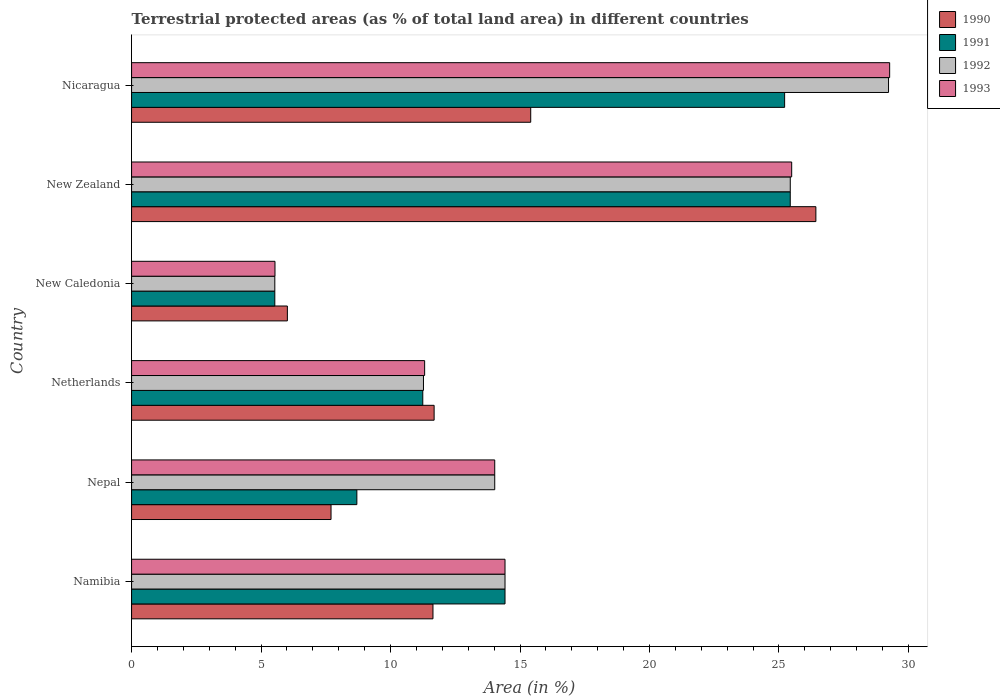How many different coloured bars are there?
Offer a terse response. 4. Are the number of bars per tick equal to the number of legend labels?
Provide a succinct answer. Yes. Are the number of bars on each tick of the Y-axis equal?
Ensure brevity in your answer.  Yes. How many bars are there on the 3rd tick from the top?
Your answer should be compact. 4. What is the label of the 2nd group of bars from the top?
Offer a very short reply. New Zealand. In how many cases, is the number of bars for a given country not equal to the number of legend labels?
Provide a short and direct response. 0. What is the percentage of terrestrial protected land in 1992 in New Zealand?
Provide a short and direct response. 25.44. Across all countries, what is the maximum percentage of terrestrial protected land in 1993?
Offer a terse response. 29.27. Across all countries, what is the minimum percentage of terrestrial protected land in 1993?
Your response must be concise. 5.54. In which country was the percentage of terrestrial protected land in 1991 maximum?
Ensure brevity in your answer.  New Zealand. In which country was the percentage of terrestrial protected land in 1992 minimum?
Provide a succinct answer. New Caledonia. What is the total percentage of terrestrial protected land in 1990 in the graph?
Provide a succinct answer. 78.88. What is the difference between the percentage of terrestrial protected land in 1991 in Netherlands and that in New Caledonia?
Make the answer very short. 5.71. What is the difference between the percentage of terrestrial protected land in 1993 in Nepal and the percentage of terrestrial protected land in 1990 in New Zealand?
Offer a very short reply. -12.4. What is the average percentage of terrestrial protected land in 1993 per country?
Make the answer very short. 16.68. What is the difference between the percentage of terrestrial protected land in 1991 and percentage of terrestrial protected land in 1992 in Netherlands?
Keep it short and to the point. -0.03. In how many countries, is the percentage of terrestrial protected land in 1993 greater than 12 %?
Offer a terse response. 4. What is the ratio of the percentage of terrestrial protected land in 1990 in Namibia to that in New Zealand?
Your answer should be compact. 0.44. Is the percentage of terrestrial protected land in 1990 in Namibia less than that in Nepal?
Your answer should be compact. No. Is the difference between the percentage of terrestrial protected land in 1991 in Nepal and Nicaragua greater than the difference between the percentage of terrestrial protected land in 1992 in Nepal and Nicaragua?
Provide a short and direct response. No. What is the difference between the highest and the second highest percentage of terrestrial protected land in 1990?
Provide a succinct answer. 11.01. What is the difference between the highest and the lowest percentage of terrestrial protected land in 1990?
Keep it short and to the point. 20.41. In how many countries, is the percentage of terrestrial protected land in 1991 greater than the average percentage of terrestrial protected land in 1991 taken over all countries?
Your response must be concise. 2. What does the 3rd bar from the top in New Caledonia represents?
Make the answer very short. 1991. How many bars are there?
Your answer should be compact. 24. Are the values on the major ticks of X-axis written in scientific E-notation?
Give a very brief answer. No. Where does the legend appear in the graph?
Ensure brevity in your answer.  Top right. How many legend labels are there?
Provide a succinct answer. 4. How are the legend labels stacked?
Your response must be concise. Vertical. What is the title of the graph?
Provide a short and direct response. Terrestrial protected areas (as % of total land area) in different countries. What is the label or title of the X-axis?
Your answer should be very brief. Area (in %). What is the label or title of the Y-axis?
Make the answer very short. Country. What is the Area (in %) in 1990 in Namibia?
Provide a succinct answer. 11.64. What is the Area (in %) in 1991 in Namibia?
Provide a short and direct response. 14.42. What is the Area (in %) in 1992 in Namibia?
Keep it short and to the point. 14.42. What is the Area (in %) in 1993 in Namibia?
Provide a short and direct response. 14.42. What is the Area (in %) in 1990 in Nepal?
Keep it short and to the point. 7.7. What is the Area (in %) in 1991 in Nepal?
Offer a very short reply. 8.7. What is the Area (in %) of 1992 in Nepal?
Provide a short and direct response. 14.02. What is the Area (in %) of 1993 in Nepal?
Keep it short and to the point. 14.02. What is the Area (in %) of 1990 in Netherlands?
Give a very brief answer. 11.68. What is the Area (in %) of 1991 in Netherlands?
Provide a succinct answer. 11.25. What is the Area (in %) in 1992 in Netherlands?
Give a very brief answer. 11.27. What is the Area (in %) in 1993 in Netherlands?
Offer a terse response. 11.32. What is the Area (in %) in 1990 in New Caledonia?
Keep it short and to the point. 6.02. What is the Area (in %) in 1991 in New Caledonia?
Your answer should be compact. 5.53. What is the Area (in %) in 1992 in New Caledonia?
Make the answer very short. 5.53. What is the Area (in %) in 1993 in New Caledonia?
Offer a terse response. 5.54. What is the Area (in %) in 1990 in New Zealand?
Your answer should be very brief. 26.42. What is the Area (in %) of 1991 in New Zealand?
Offer a terse response. 25.44. What is the Area (in %) in 1992 in New Zealand?
Keep it short and to the point. 25.44. What is the Area (in %) of 1993 in New Zealand?
Make the answer very short. 25.49. What is the Area (in %) of 1990 in Nicaragua?
Keep it short and to the point. 15.41. What is the Area (in %) in 1991 in Nicaragua?
Your answer should be very brief. 25.22. What is the Area (in %) of 1992 in Nicaragua?
Give a very brief answer. 29.23. What is the Area (in %) of 1993 in Nicaragua?
Ensure brevity in your answer.  29.27. Across all countries, what is the maximum Area (in %) of 1990?
Make the answer very short. 26.42. Across all countries, what is the maximum Area (in %) in 1991?
Provide a short and direct response. 25.44. Across all countries, what is the maximum Area (in %) of 1992?
Offer a very short reply. 29.23. Across all countries, what is the maximum Area (in %) of 1993?
Ensure brevity in your answer.  29.27. Across all countries, what is the minimum Area (in %) of 1990?
Provide a short and direct response. 6.02. Across all countries, what is the minimum Area (in %) of 1991?
Your answer should be compact. 5.53. Across all countries, what is the minimum Area (in %) in 1992?
Your answer should be very brief. 5.53. Across all countries, what is the minimum Area (in %) in 1993?
Your answer should be very brief. 5.54. What is the total Area (in %) of 1990 in the graph?
Your answer should be compact. 78.88. What is the total Area (in %) in 1991 in the graph?
Ensure brevity in your answer.  90.55. What is the total Area (in %) of 1992 in the graph?
Ensure brevity in your answer.  99.91. What is the total Area (in %) of 1993 in the graph?
Keep it short and to the point. 100.06. What is the difference between the Area (in %) in 1990 in Namibia and that in Nepal?
Make the answer very short. 3.94. What is the difference between the Area (in %) in 1991 in Namibia and that in Nepal?
Make the answer very short. 5.72. What is the difference between the Area (in %) of 1992 in Namibia and that in Nepal?
Your answer should be very brief. 0.4. What is the difference between the Area (in %) in 1993 in Namibia and that in Nepal?
Ensure brevity in your answer.  0.4. What is the difference between the Area (in %) of 1990 in Namibia and that in Netherlands?
Your answer should be very brief. -0.04. What is the difference between the Area (in %) of 1991 in Namibia and that in Netherlands?
Provide a succinct answer. 3.18. What is the difference between the Area (in %) in 1992 in Namibia and that in Netherlands?
Provide a succinct answer. 3.15. What is the difference between the Area (in %) of 1993 in Namibia and that in Netherlands?
Offer a very short reply. 3.1. What is the difference between the Area (in %) of 1990 in Namibia and that in New Caledonia?
Your response must be concise. 5.62. What is the difference between the Area (in %) in 1991 in Namibia and that in New Caledonia?
Your answer should be very brief. 8.89. What is the difference between the Area (in %) of 1992 in Namibia and that in New Caledonia?
Your response must be concise. 8.89. What is the difference between the Area (in %) of 1993 in Namibia and that in New Caledonia?
Ensure brevity in your answer.  8.88. What is the difference between the Area (in %) of 1990 in Namibia and that in New Zealand?
Your response must be concise. -14.79. What is the difference between the Area (in %) in 1991 in Namibia and that in New Zealand?
Your answer should be very brief. -11.01. What is the difference between the Area (in %) in 1992 in Namibia and that in New Zealand?
Provide a succinct answer. -11.02. What is the difference between the Area (in %) in 1993 in Namibia and that in New Zealand?
Offer a terse response. -11.07. What is the difference between the Area (in %) in 1990 in Namibia and that in Nicaragua?
Make the answer very short. -3.77. What is the difference between the Area (in %) of 1991 in Namibia and that in Nicaragua?
Provide a succinct answer. -10.8. What is the difference between the Area (in %) of 1992 in Namibia and that in Nicaragua?
Make the answer very short. -14.81. What is the difference between the Area (in %) of 1993 in Namibia and that in Nicaragua?
Keep it short and to the point. -14.85. What is the difference between the Area (in %) of 1990 in Nepal and that in Netherlands?
Your answer should be very brief. -3.98. What is the difference between the Area (in %) in 1991 in Nepal and that in Netherlands?
Your answer should be very brief. -2.55. What is the difference between the Area (in %) in 1992 in Nepal and that in Netherlands?
Your answer should be compact. 2.75. What is the difference between the Area (in %) of 1993 in Nepal and that in Netherlands?
Your answer should be compact. 2.71. What is the difference between the Area (in %) in 1990 in Nepal and that in New Caledonia?
Your answer should be very brief. 1.69. What is the difference between the Area (in %) in 1991 in Nepal and that in New Caledonia?
Your answer should be very brief. 3.17. What is the difference between the Area (in %) of 1992 in Nepal and that in New Caledonia?
Your answer should be very brief. 8.49. What is the difference between the Area (in %) of 1993 in Nepal and that in New Caledonia?
Make the answer very short. 8.49. What is the difference between the Area (in %) in 1990 in Nepal and that in New Zealand?
Make the answer very short. -18.72. What is the difference between the Area (in %) of 1991 in Nepal and that in New Zealand?
Your response must be concise. -16.74. What is the difference between the Area (in %) of 1992 in Nepal and that in New Zealand?
Your answer should be very brief. -11.41. What is the difference between the Area (in %) in 1993 in Nepal and that in New Zealand?
Give a very brief answer. -11.47. What is the difference between the Area (in %) of 1990 in Nepal and that in Nicaragua?
Your response must be concise. -7.71. What is the difference between the Area (in %) of 1991 in Nepal and that in Nicaragua?
Keep it short and to the point. -16.52. What is the difference between the Area (in %) of 1992 in Nepal and that in Nicaragua?
Your response must be concise. -15.21. What is the difference between the Area (in %) in 1993 in Nepal and that in Nicaragua?
Offer a very short reply. -15.25. What is the difference between the Area (in %) of 1990 in Netherlands and that in New Caledonia?
Keep it short and to the point. 5.67. What is the difference between the Area (in %) of 1991 in Netherlands and that in New Caledonia?
Make the answer very short. 5.71. What is the difference between the Area (in %) of 1992 in Netherlands and that in New Caledonia?
Give a very brief answer. 5.74. What is the difference between the Area (in %) of 1993 in Netherlands and that in New Caledonia?
Offer a very short reply. 5.78. What is the difference between the Area (in %) in 1990 in Netherlands and that in New Zealand?
Provide a succinct answer. -14.74. What is the difference between the Area (in %) of 1991 in Netherlands and that in New Zealand?
Your answer should be very brief. -14.19. What is the difference between the Area (in %) in 1992 in Netherlands and that in New Zealand?
Make the answer very short. -14.16. What is the difference between the Area (in %) of 1993 in Netherlands and that in New Zealand?
Your answer should be very brief. -14.17. What is the difference between the Area (in %) of 1990 in Netherlands and that in Nicaragua?
Give a very brief answer. -3.73. What is the difference between the Area (in %) of 1991 in Netherlands and that in Nicaragua?
Provide a succinct answer. -13.97. What is the difference between the Area (in %) in 1992 in Netherlands and that in Nicaragua?
Make the answer very short. -17.96. What is the difference between the Area (in %) of 1993 in Netherlands and that in Nicaragua?
Your answer should be very brief. -17.96. What is the difference between the Area (in %) in 1990 in New Caledonia and that in New Zealand?
Your answer should be very brief. -20.41. What is the difference between the Area (in %) in 1991 in New Caledonia and that in New Zealand?
Ensure brevity in your answer.  -19.9. What is the difference between the Area (in %) of 1992 in New Caledonia and that in New Zealand?
Keep it short and to the point. -19.9. What is the difference between the Area (in %) in 1993 in New Caledonia and that in New Zealand?
Your response must be concise. -19.95. What is the difference between the Area (in %) of 1990 in New Caledonia and that in Nicaragua?
Provide a short and direct response. -9.4. What is the difference between the Area (in %) in 1991 in New Caledonia and that in Nicaragua?
Keep it short and to the point. -19.69. What is the difference between the Area (in %) of 1992 in New Caledonia and that in Nicaragua?
Offer a very short reply. -23.7. What is the difference between the Area (in %) of 1993 in New Caledonia and that in Nicaragua?
Keep it short and to the point. -23.74. What is the difference between the Area (in %) in 1990 in New Zealand and that in Nicaragua?
Your response must be concise. 11.01. What is the difference between the Area (in %) in 1991 in New Zealand and that in Nicaragua?
Provide a succinct answer. 0.22. What is the difference between the Area (in %) in 1992 in New Zealand and that in Nicaragua?
Your answer should be very brief. -3.79. What is the difference between the Area (in %) of 1993 in New Zealand and that in Nicaragua?
Your answer should be very brief. -3.78. What is the difference between the Area (in %) of 1990 in Namibia and the Area (in %) of 1991 in Nepal?
Provide a succinct answer. 2.94. What is the difference between the Area (in %) of 1990 in Namibia and the Area (in %) of 1992 in Nepal?
Offer a very short reply. -2.39. What is the difference between the Area (in %) in 1990 in Namibia and the Area (in %) in 1993 in Nepal?
Provide a succinct answer. -2.39. What is the difference between the Area (in %) in 1991 in Namibia and the Area (in %) in 1992 in Nepal?
Provide a short and direct response. 0.4. What is the difference between the Area (in %) of 1991 in Namibia and the Area (in %) of 1993 in Nepal?
Make the answer very short. 0.4. What is the difference between the Area (in %) in 1992 in Namibia and the Area (in %) in 1993 in Nepal?
Ensure brevity in your answer.  0.4. What is the difference between the Area (in %) in 1990 in Namibia and the Area (in %) in 1991 in Netherlands?
Offer a terse response. 0.39. What is the difference between the Area (in %) of 1990 in Namibia and the Area (in %) of 1992 in Netherlands?
Offer a very short reply. 0.37. What is the difference between the Area (in %) of 1990 in Namibia and the Area (in %) of 1993 in Netherlands?
Ensure brevity in your answer.  0.32. What is the difference between the Area (in %) in 1991 in Namibia and the Area (in %) in 1992 in Netherlands?
Give a very brief answer. 3.15. What is the difference between the Area (in %) in 1991 in Namibia and the Area (in %) in 1993 in Netherlands?
Make the answer very short. 3.1. What is the difference between the Area (in %) of 1992 in Namibia and the Area (in %) of 1993 in Netherlands?
Offer a terse response. 3.1. What is the difference between the Area (in %) of 1990 in Namibia and the Area (in %) of 1991 in New Caledonia?
Offer a very short reply. 6.11. What is the difference between the Area (in %) of 1990 in Namibia and the Area (in %) of 1992 in New Caledonia?
Give a very brief answer. 6.11. What is the difference between the Area (in %) of 1990 in Namibia and the Area (in %) of 1993 in New Caledonia?
Offer a terse response. 6.1. What is the difference between the Area (in %) in 1991 in Namibia and the Area (in %) in 1992 in New Caledonia?
Provide a short and direct response. 8.89. What is the difference between the Area (in %) in 1991 in Namibia and the Area (in %) in 1993 in New Caledonia?
Keep it short and to the point. 8.88. What is the difference between the Area (in %) in 1992 in Namibia and the Area (in %) in 1993 in New Caledonia?
Give a very brief answer. 8.88. What is the difference between the Area (in %) in 1990 in Namibia and the Area (in %) in 1991 in New Zealand?
Ensure brevity in your answer.  -13.8. What is the difference between the Area (in %) of 1990 in Namibia and the Area (in %) of 1992 in New Zealand?
Provide a succinct answer. -13.8. What is the difference between the Area (in %) in 1990 in Namibia and the Area (in %) in 1993 in New Zealand?
Provide a succinct answer. -13.85. What is the difference between the Area (in %) of 1991 in Namibia and the Area (in %) of 1992 in New Zealand?
Ensure brevity in your answer.  -11.02. What is the difference between the Area (in %) in 1991 in Namibia and the Area (in %) in 1993 in New Zealand?
Provide a succinct answer. -11.07. What is the difference between the Area (in %) of 1992 in Namibia and the Area (in %) of 1993 in New Zealand?
Your answer should be very brief. -11.07. What is the difference between the Area (in %) of 1990 in Namibia and the Area (in %) of 1991 in Nicaragua?
Offer a very short reply. -13.58. What is the difference between the Area (in %) in 1990 in Namibia and the Area (in %) in 1992 in Nicaragua?
Your response must be concise. -17.59. What is the difference between the Area (in %) of 1990 in Namibia and the Area (in %) of 1993 in Nicaragua?
Ensure brevity in your answer.  -17.64. What is the difference between the Area (in %) in 1991 in Namibia and the Area (in %) in 1992 in Nicaragua?
Provide a succinct answer. -14.81. What is the difference between the Area (in %) of 1991 in Namibia and the Area (in %) of 1993 in Nicaragua?
Offer a very short reply. -14.85. What is the difference between the Area (in %) of 1992 in Namibia and the Area (in %) of 1993 in Nicaragua?
Make the answer very short. -14.85. What is the difference between the Area (in %) of 1990 in Nepal and the Area (in %) of 1991 in Netherlands?
Your answer should be compact. -3.54. What is the difference between the Area (in %) in 1990 in Nepal and the Area (in %) in 1992 in Netherlands?
Give a very brief answer. -3.57. What is the difference between the Area (in %) of 1990 in Nepal and the Area (in %) of 1993 in Netherlands?
Your answer should be compact. -3.61. What is the difference between the Area (in %) in 1991 in Nepal and the Area (in %) in 1992 in Netherlands?
Your answer should be compact. -2.57. What is the difference between the Area (in %) of 1991 in Nepal and the Area (in %) of 1993 in Netherlands?
Offer a terse response. -2.62. What is the difference between the Area (in %) in 1992 in Nepal and the Area (in %) in 1993 in Netherlands?
Your response must be concise. 2.71. What is the difference between the Area (in %) in 1990 in Nepal and the Area (in %) in 1991 in New Caledonia?
Provide a succinct answer. 2.17. What is the difference between the Area (in %) of 1990 in Nepal and the Area (in %) of 1992 in New Caledonia?
Provide a succinct answer. 2.17. What is the difference between the Area (in %) in 1990 in Nepal and the Area (in %) in 1993 in New Caledonia?
Your answer should be compact. 2.16. What is the difference between the Area (in %) in 1991 in Nepal and the Area (in %) in 1992 in New Caledonia?
Provide a succinct answer. 3.17. What is the difference between the Area (in %) of 1991 in Nepal and the Area (in %) of 1993 in New Caledonia?
Offer a very short reply. 3.16. What is the difference between the Area (in %) in 1992 in Nepal and the Area (in %) in 1993 in New Caledonia?
Give a very brief answer. 8.49. What is the difference between the Area (in %) of 1990 in Nepal and the Area (in %) of 1991 in New Zealand?
Your response must be concise. -17.73. What is the difference between the Area (in %) in 1990 in Nepal and the Area (in %) in 1992 in New Zealand?
Make the answer very short. -17.73. What is the difference between the Area (in %) in 1990 in Nepal and the Area (in %) in 1993 in New Zealand?
Your answer should be compact. -17.79. What is the difference between the Area (in %) of 1991 in Nepal and the Area (in %) of 1992 in New Zealand?
Your response must be concise. -16.74. What is the difference between the Area (in %) in 1991 in Nepal and the Area (in %) in 1993 in New Zealand?
Keep it short and to the point. -16.79. What is the difference between the Area (in %) in 1992 in Nepal and the Area (in %) in 1993 in New Zealand?
Provide a short and direct response. -11.47. What is the difference between the Area (in %) in 1990 in Nepal and the Area (in %) in 1991 in Nicaragua?
Your answer should be compact. -17.52. What is the difference between the Area (in %) of 1990 in Nepal and the Area (in %) of 1992 in Nicaragua?
Make the answer very short. -21.53. What is the difference between the Area (in %) of 1990 in Nepal and the Area (in %) of 1993 in Nicaragua?
Keep it short and to the point. -21.57. What is the difference between the Area (in %) of 1991 in Nepal and the Area (in %) of 1992 in Nicaragua?
Ensure brevity in your answer.  -20.53. What is the difference between the Area (in %) in 1991 in Nepal and the Area (in %) in 1993 in Nicaragua?
Give a very brief answer. -20.57. What is the difference between the Area (in %) in 1992 in Nepal and the Area (in %) in 1993 in Nicaragua?
Your answer should be very brief. -15.25. What is the difference between the Area (in %) of 1990 in Netherlands and the Area (in %) of 1991 in New Caledonia?
Your response must be concise. 6.15. What is the difference between the Area (in %) of 1990 in Netherlands and the Area (in %) of 1992 in New Caledonia?
Offer a terse response. 6.15. What is the difference between the Area (in %) in 1990 in Netherlands and the Area (in %) in 1993 in New Caledonia?
Provide a short and direct response. 6.15. What is the difference between the Area (in %) in 1991 in Netherlands and the Area (in %) in 1992 in New Caledonia?
Ensure brevity in your answer.  5.71. What is the difference between the Area (in %) of 1991 in Netherlands and the Area (in %) of 1993 in New Caledonia?
Offer a terse response. 5.71. What is the difference between the Area (in %) in 1992 in Netherlands and the Area (in %) in 1993 in New Caledonia?
Make the answer very short. 5.73. What is the difference between the Area (in %) in 1990 in Netherlands and the Area (in %) in 1991 in New Zealand?
Your response must be concise. -13.75. What is the difference between the Area (in %) in 1990 in Netherlands and the Area (in %) in 1992 in New Zealand?
Your answer should be compact. -13.75. What is the difference between the Area (in %) in 1990 in Netherlands and the Area (in %) in 1993 in New Zealand?
Offer a very short reply. -13.81. What is the difference between the Area (in %) of 1991 in Netherlands and the Area (in %) of 1992 in New Zealand?
Give a very brief answer. -14.19. What is the difference between the Area (in %) of 1991 in Netherlands and the Area (in %) of 1993 in New Zealand?
Make the answer very short. -14.25. What is the difference between the Area (in %) in 1992 in Netherlands and the Area (in %) in 1993 in New Zealand?
Your answer should be very brief. -14.22. What is the difference between the Area (in %) in 1990 in Netherlands and the Area (in %) in 1991 in Nicaragua?
Offer a terse response. -13.54. What is the difference between the Area (in %) of 1990 in Netherlands and the Area (in %) of 1992 in Nicaragua?
Provide a short and direct response. -17.55. What is the difference between the Area (in %) of 1990 in Netherlands and the Area (in %) of 1993 in Nicaragua?
Your answer should be very brief. -17.59. What is the difference between the Area (in %) of 1991 in Netherlands and the Area (in %) of 1992 in Nicaragua?
Your answer should be very brief. -17.98. What is the difference between the Area (in %) of 1991 in Netherlands and the Area (in %) of 1993 in Nicaragua?
Offer a very short reply. -18.03. What is the difference between the Area (in %) of 1992 in Netherlands and the Area (in %) of 1993 in Nicaragua?
Make the answer very short. -18. What is the difference between the Area (in %) of 1990 in New Caledonia and the Area (in %) of 1991 in New Zealand?
Offer a very short reply. -19.42. What is the difference between the Area (in %) of 1990 in New Caledonia and the Area (in %) of 1992 in New Zealand?
Offer a very short reply. -19.42. What is the difference between the Area (in %) of 1990 in New Caledonia and the Area (in %) of 1993 in New Zealand?
Give a very brief answer. -19.47. What is the difference between the Area (in %) in 1991 in New Caledonia and the Area (in %) in 1992 in New Zealand?
Offer a terse response. -19.9. What is the difference between the Area (in %) of 1991 in New Caledonia and the Area (in %) of 1993 in New Zealand?
Your response must be concise. -19.96. What is the difference between the Area (in %) in 1992 in New Caledonia and the Area (in %) in 1993 in New Zealand?
Make the answer very short. -19.96. What is the difference between the Area (in %) in 1990 in New Caledonia and the Area (in %) in 1991 in Nicaragua?
Your answer should be compact. -19.2. What is the difference between the Area (in %) in 1990 in New Caledonia and the Area (in %) in 1992 in Nicaragua?
Your response must be concise. -23.21. What is the difference between the Area (in %) in 1990 in New Caledonia and the Area (in %) in 1993 in Nicaragua?
Your answer should be very brief. -23.26. What is the difference between the Area (in %) of 1991 in New Caledonia and the Area (in %) of 1992 in Nicaragua?
Keep it short and to the point. -23.7. What is the difference between the Area (in %) in 1991 in New Caledonia and the Area (in %) in 1993 in Nicaragua?
Your response must be concise. -23.74. What is the difference between the Area (in %) in 1992 in New Caledonia and the Area (in %) in 1993 in Nicaragua?
Provide a short and direct response. -23.74. What is the difference between the Area (in %) in 1990 in New Zealand and the Area (in %) in 1991 in Nicaragua?
Provide a succinct answer. 1.21. What is the difference between the Area (in %) in 1990 in New Zealand and the Area (in %) in 1992 in Nicaragua?
Provide a short and direct response. -2.81. What is the difference between the Area (in %) in 1990 in New Zealand and the Area (in %) in 1993 in Nicaragua?
Offer a terse response. -2.85. What is the difference between the Area (in %) of 1991 in New Zealand and the Area (in %) of 1992 in Nicaragua?
Offer a very short reply. -3.79. What is the difference between the Area (in %) in 1991 in New Zealand and the Area (in %) in 1993 in Nicaragua?
Your response must be concise. -3.84. What is the difference between the Area (in %) of 1992 in New Zealand and the Area (in %) of 1993 in Nicaragua?
Provide a succinct answer. -3.84. What is the average Area (in %) in 1990 per country?
Ensure brevity in your answer.  13.15. What is the average Area (in %) of 1991 per country?
Ensure brevity in your answer.  15.09. What is the average Area (in %) of 1992 per country?
Your answer should be compact. 16.65. What is the average Area (in %) of 1993 per country?
Offer a terse response. 16.68. What is the difference between the Area (in %) in 1990 and Area (in %) in 1991 in Namibia?
Make the answer very short. -2.78. What is the difference between the Area (in %) of 1990 and Area (in %) of 1992 in Namibia?
Make the answer very short. -2.78. What is the difference between the Area (in %) of 1990 and Area (in %) of 1993 in Namibia?
Ensure brevity in your answer.  -2.78. What is the difference between the Area (in %) of 1991 and Area (in %) of 1992 in Namibia?
Offer a very short reply. 0. What is the difference between the Area (in %) in 1992 and Area (in %) in 1993 in Namibia?
Offer a terse response. 0. What is the difference between the Area (in %) of 1990 and Area (in %) of 1991 in Nepal?
Give a very brief answer. -1. What is the difference between the Area (in %) in 1990 and Area (in %) in 1992 in Nepal?
Your response must be concise. -6.32. What is the difference between the Area (in %) in 1990 and Area (in %) in 1993 in Nepal?
Provide a succinct answer. -6.32. What is the difference between the Area (in %) of 1991 and Area (in %) of 1992 in Nepal?
Offer a terse response. -5.32. What is the difference between the Area (in %) of 1991 and Area (in %) of 1993 in Nepal?
Your answer should be very brief. -5.32. What is the difference between the Area (in %) of 1992 and Area (in %) of 1993 in Nepal?
Keep it short and to the point. 0. What is the difference between the Area (in %) of 1990 and Area (in %) of 1991 in Netherlands?
Offer a terse response. 0.44. What is the difference between the Area (in %) of 1990 and Area (in %) of 1992 in Netherlands?
Ensure brevity in your answer.  0.41. What is the difference between the Area (in %) of 1990 and Area (in %) of 1993 in Netherlands?
Offer a very short reply. 0.37. What is the difference between the Area (in %) in 1991 and Area (in %) in 1992 in Netherlands?
Offer a very short reply. -0.03. What is the difference between the Area (in %) in 1991 and Area (in %) in 1993 in Netherlands?
Your answer should be compact. -0.07. What is the difference between the Area (in %) of 1992 and Area (in %) of 1993 in Netherlands?
Offer a very short reply. -0.05. What is the difference between the Area (in %) of 1990 and Area (in %) of 1991 in New Caledonia?
Ensure brevity in your answer.  0.48. What is the difference between the Area (in %) in 1990 and Area (in %) in 1992 in New Caledonia?
Give a very brief answer. 0.48. What is the difference between the Area (in %) in 1990 and Area (in %) in 1993 in New Caledonia?
Offer a very short reply. 0.48. What is the difference between the Area (in %) in 1991 and Area (in %) in 1993 in New Caledonia?
Your answer should be very brief. -0.01. What is the difference between the Area (in %) of 1992 and Area (in %) of 1993 in New Caledonia?
Make the answer very short. -0.01. What is the difference between the Area (in %) of 1990 and Area (in %) of 1993 in New Zealand?
Your response must be concise. 0.93. What is the difference between the Area (in %) of 1991 and Area (in %) of 1992 in New Zealand?
Your response must be concise. -0. What is the difference between the Area (in %) of 1991 and Area (in %) of 1993 in New Zealand?
Provide a succinct answer. -0.06. What is the difference between the Area (in %) in 1992 and Area (in %) in 1993 in New Zealand?
Keep it short and to the point. -0.06. What is the difference between the Area (in %) of 1990 and Area (in %) of 1991 in Nicaragua?
Offer a terse response. -9.81. What is the difference between the Area (in %) in 1990 and Area (in %) in 1992 in Nicaragua?
Make the answer very short. -13.82. What is the difference between the Area (in %) of 1990 and Area (in %) of 1993 in Nicaragua?
Provide a short and direct response. -13.86. What is the difference between the Area (in %) of 1991 and Area (in %) of 1992 in Nicaragua?
Ensure brevity in your answer.  -4.01. What is the difference between the Area (in %) of 1991 and Area (in %) of 1993 in Nicaragua?
Provide a short and direct response. -4.06. What is the difference between the Area (in %) in 1992 and Area (in %) in 1993 in Nicaragua?
Your response must be concise. -0.04. What is the ratio of the Area (in %) in 1990 in Namibia to that in Nepal?
Keep it short and to the point. 1.51. What is the ratio of the Area (in %) of 1991 in Namibia to that in Nepal?
Offer a very short reply. 1.66. What is the ratio of the Area (in %) of 1992 in Namibia to that in Nepal?
Offer a very short reply. 1.03. What is the ratio of the Area (in %) of 1993 in Namibia to that in Nepal?
Your answer should be compact. 1.03. What is the ratio of the Area (in %) in 1991 in Namibia to that in Netherlands?
Provide a short and direct response. 1.28. What is the ratio of the Area (in %) in 1992 in Namibia to that in Netherlands?
Your response must be concise. 1.28. What is the ratio of the Area (in %) of 1993 in Namibia to that in Netherlands?
Ensure brevity in your answer.  1.27. What is the ratio of the Area (in %) of 1990 in Namibia to that in New Caledonia?
Your response must be concise. 1.93. What is the ratio of the Area (in %) of 1991 in Namibia to that in New Caledonia?
Offer a terse response. 2.61. What is the ratio of the Area (in %) of 1992 in Namibia to that in New Caledonia?
Keep it short and to the point. 2.61. What is the ratio of the Area (in %) in 1993 in Namibia to that in New Caledonia?
Give a very brief answer. 2.6. What is the ratio of the Area (in %) of 1990 in Namibia to that in New Zealand?
Your response must be concise. 0.44. What is the ratio of the Area (in %) of 1991 in Namibia to that in New Zealand?
Make the answer very short. 0.57. What is the ratio of the Area (in %) in 1992 in Namibia to that in New Zealand?
Offer a very short reply. 0.57. What is the ratio of the Area (in %) in 1993 in Namibia to that in New Zealand?
Ensure brevity in your answer.  0.57. What is the ratio of the Area (in %) of 1990 in Namibia to that in Nicaragua?
Ensure brevity in your answer.  0.76. What is the ratio of the Area (in %) of 1991 in Namibia to that in Nicaragua?
Your answer should be compact. 0.57. What is the ratio of the Area (in %) in 1992 in Namibia to that in Nicaragua?
Your answer should be very brief. 0.49. What is the ratio of the Area (in %) in 1993 in Namibia to that in Nicaragua?
Keep it short and to the point. 0.49. What is the ratio of the Area (in %) of 1990 in Nepal to that in Netherlands?
Provide a short and direct response. 0.66. What is the ratio of the Area (in %) in 1991 in Nepal to that in Netherlands?
Provide a succinct answer. 0.77. What is the ratio of the Area (in %) of 1992 in Nepal to that in Netherlands?
Your response must be concise. 1.24. What is the ratio of the Area (in %) in 1993 in Nepal to that in Netherlands?
Offer a terse response. 1.24. What is the ratio of the Area (in %) of 1990 in Nepal to that in New Caledonia?
Your answer should be compact. 1.28. What is the ratio of the Area (in %) of 1991 in Nepal to that in New Caledonia?
Give a very brief answer. 1.57. What is the ratio of the Area (in %) of 1992 in Nepal to that in New Caledonia?
Keep it short and to the point. 2.54. What is the ratio of the Area (in %) in 1993 in Nepal to that in New Caledonia?
Your answer should be very brief. 2.53. What is the ratio of the Area (in %) of 1990 in Nepal to that in New Zealand?
Make the answer very short. 0.29. What is the ratio of the Area (in %) in 1991 in Nepal to that in New Zealand?
Give a very brief answer. 0.34. What is the ratio of the Area (in %) of 1992 in Nepal to that in New Zealand?
Ensure brevity in your answer.  0.55. What is the ratio of the Area (in %) of 1993 in Nepal to that in New Zealand?
Your answer should be compact. 0.55. What is the ratio of the Area (in %) of 1990 in Nepal to that in Nicaragua?
Keep it short and to the point. 0.5. What is the ratio of the Area (in %) in 1991 in Nepal to that in Nicaragua?
Keep it short and to the point. 0.34. What is the ratio of the Area (in %) in 1992 in Nepal to that in Nicaragua?
Give a very brief answer. 0.48. What is the ratio of the Area (in %) of 1993 in Nepal to that in Nicaragua?
Offer a terse response. 0.48. What is the ratio of the Area (in %) in 1990 in Netherlands to that in New Caledonia?
Provide a short and direct response. 1.94. What is the ratio of the Area (in %) of 1991 in Netherlands to that in New Caledonia?
Offer a very short reply. 2.03. What is the ratio of the Area (in %) in 1992 in Netherlands to that in New Caledonia?
Offer a terse response. 2.04. What is the ratio of the Area (in %) of 1993 in Netherlands to that in New Caledonia?
Give a very brief answer. 2.04. What is the ratio of the Area (in %) in 1990 in Netherlands to that in New Zealand?
Keep it short and to the point. 0.44. What is the ratio of the Area (in %) of 1991 in Netherlands to that in New Zealand?
Keep it short and to the point. 0.44. What is the ratio of the Area (in %) in 1992 in Netherlands to that in New Zealand?
Your answer should be compact. 0.44. What is the ratio of the Area (in %) in 1993 in Netherlands to that in New Zealand?
Give a very brief answer. 0.44. What is the ratio of the Area (in %) of 1990 in Netherlands to that in Nicaragua?
Provide a succinct answer. 0.76. What is the ratio of the Area (in %) of 1991 in Netherlands to that in Nicaragua?
Offer a terse response. 0.45. What is the ratio of the Area (in %) in 1992 in Netherlands to that in Nicaragua?
Give a very brief answer. 0.39. What is the ratio of the Area (in %) of 1993 in Netherlands to that in Nicaragua?
Provide a succinct answer. 0.39. What is the ratio of the Area (in %) in 1990 in New Caledonia to that in New Zealand?
Keep it short and to the point. 0.23. What is the ratio of the Area (in %) in 1991 in New Caledonia to that in New Zealand?
Make the answer very short. 0.22. What is the ratio of the Area (in %) of 1992 in New Caledonia to that in New Zealand?
Offer a very short reply. 0.22. What is the ratio of the Area (in %) in 1993 in New Caledonia to that in New Zealand?
Offer a terse response. 0.22. What is the ratio of the Area (in %) of 1990 in New Caledonia to that in Nicaragua?
Your answer should be compact. 0.39. What is the ratio of the Area (in %) in 1991 in New Caledonia to that in Nicaragua?
Your answer should be compact. 0.22. What is the ratio of the Area (in %) of 1992 in New Caledonia to that in Nicaragua?
Your response must be concise. 0.19. What is the ratio of the Area (in %) in 1993 in New Caledonia to that in Nicaragua?
Offer a very short reply. 0.19. What is the ratio of the Area (in %) in 1990 in New Zealand to that in Nicaragua?
Make the answer very short. 1.71. What is the ratio of the Area (in %) in 1991 in New Zealand to that in Nicaragua?
Keep it short and to the point. 1.01. What is the ratio of the Area (in %) of 1992 in New Zealand to that in Nicaragua?
Your answer should be compact. 0.87. What is the ratio of the Area (in %) of 1993 in New Zealand to that in Nicaragua?
Your response must be concise. 0.87. What is the difference between the highest and the second highest Area (in %) of 1990?
Ensure brevity in your answer.  11.01. What is the difference between the highest and the second highest Area (in %) in 1991?
Make the answer very short. 0.22. What is the difference between the highest and the second highest Area (in %) in 1992?
Ensure brevity in your answer.  3.79. What is the difference between the highest and the second highest Area (in %) of 1993?
Offer a very short reply. 3.78. What is the difference between the highest and the lowest Area (in %) in 1990?
Ensure brevity in your answer.  20.41. What is the difference between the highest and the lowest Area (in %) in 1991?
Your response must be concise. 19.9. What is the difference between the highest and the lowest Area (in %) of 1992?
Give a very brief answer. 23.7. What is the difference between the highest and the lowest Area (in %) in 1993?
Your answer should be very brief. 23.74. 